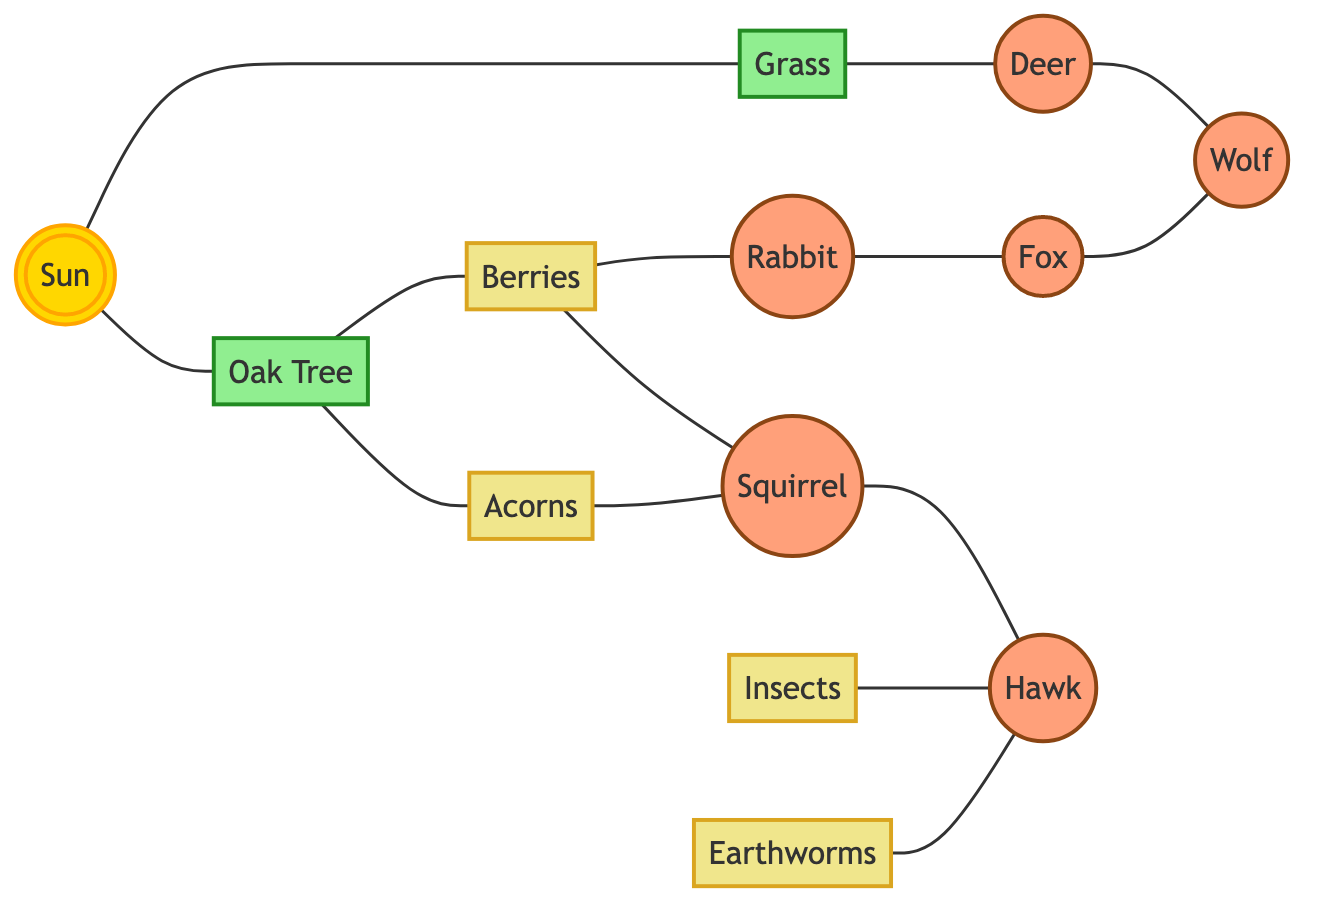What are the primary producers in this food web? The primary producers are the organisms that produce energy from sunlight, which, in this case, are the Sun, Grass, and Oak Tree. These nodes are connected directly to the Sun, showing they rely on sunlight for energy.
Answer: Sun, Grass, Oak Tree How many edges are there in the diagram? To find the total number of edges, we can count the connections between the nodes listed in the edges section of the data. There are 13 edges connecting different nodes in the food web.
Answer: 13 Which animal is a direct prey of the Deer? The Deer has a direct edge that connects it to the Wolf, indicating that the Wolf preys on the Deer. The edge leads directly from Deer to Wolf within the food web.
Answer: Wolf Which two nodes are connected through Squirrel? The Squirrel has edges leading to Acorns and Hawk. Therefore, the nodes connected through Squirrel include both Acorns and Hawk. The flow can be traced from Squirrel to these two nodes.
Answer: Acorns, Hawk How many herbivores are present in the diagram? Herbivores are organisms that primarily eat plants. The herbivores identified in this food web include Deer, Rabbit, and Squirrel. Counting these nodes provides a total of three herbivores present in the diagram.
Answer: 3 What role does the Sun play in this food web? The Sun is the ultimate source of energy in this food web, as indicated by its connections to both Grass and Oak Tree. It provides the necessary energy for these primary producers to grow and thrive, forming the foundation of the food web.
Answer: Energy source Which two types of animals are connected via Berries? Berries has direct edges connecting to both Squirrel and Rabbit. The presence of these edges indicates that these two animals have a direct relationship through Berries, meaning they both consume this food source.
Answer: Squirrel, Rabbit Which animal is at the top of the food chain in this ecosystem? The Wolf is identified as at the top of the food chain due to its connections, such as its prey, Deer, and its connection to the Fox, showing it is a predator of other animals in the ecosystem.
Answer: Wolf 